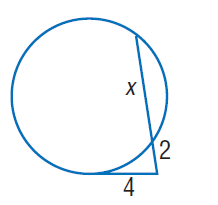Answer the mathemtical geometry problem and directly provide the correct option letter.
Question: Find x. Round to the nearest tenth if necessary. Assume that segments that appear to be tangent are tangent.
Choices: A: 2 B: 4 C: 6 D: 8 C 